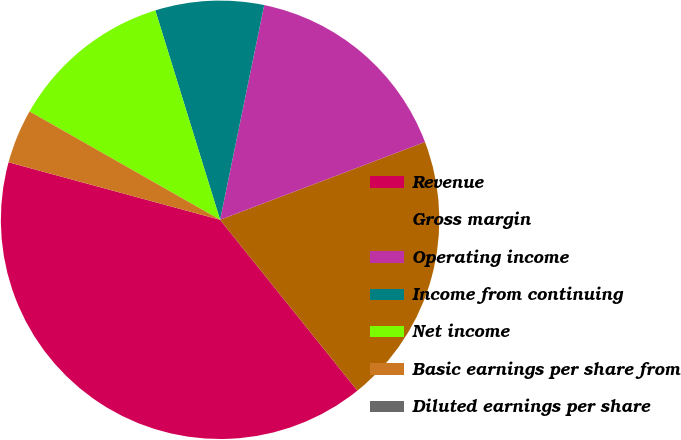Convert chart to OTSL. <chart><loc_0><loc_0><loc_500><loc_500><pie_chart><fcel>Revenue<fcel>Gross margin<fcel>Operating income<fcel>Income from continuing<fcel>Net income<fcel>Basic earnings per share from<fcel>Diluted earnings per share<nl><fcel>40.0%<fcel>20.0%<fcel>16.0%<fcel>8.0%<fcel>12.0%<fcel>4.0%<fcel>0.0%<nl></chart> 